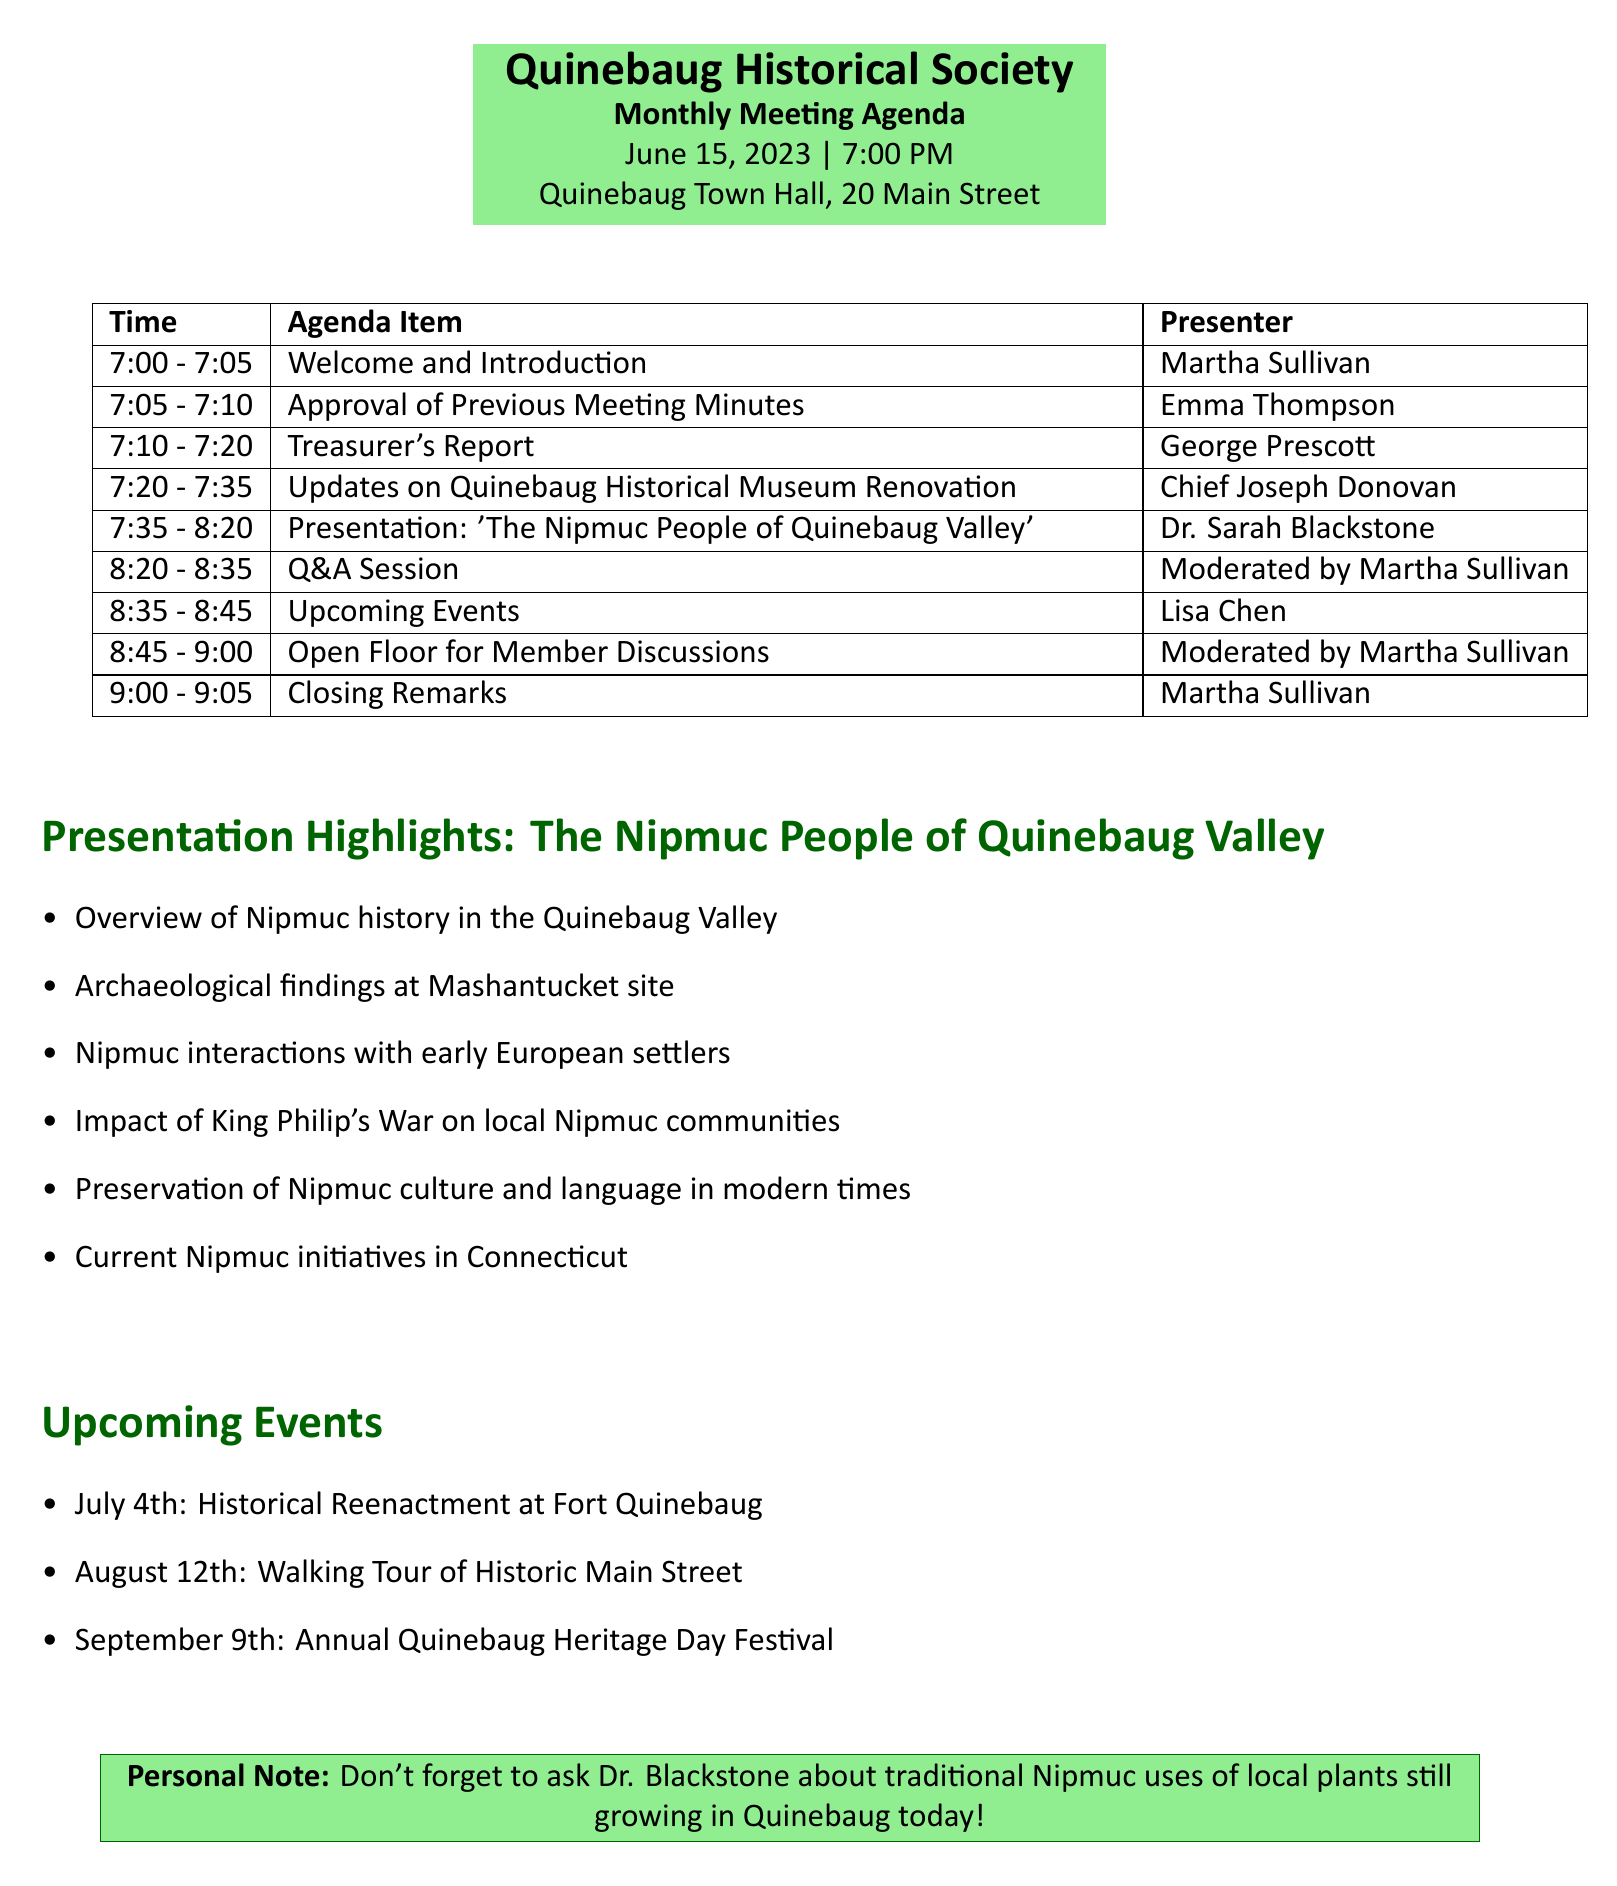What is the date of the meeting? The date of the meeting can be found in the meeting details section of the document.
Answer: June 15, 2023 Who is the presenter for the Treasurer's Report? The presenter for the Treasurer's Report is listed in the agenda items.
Answer: George Prescott What time does the meeting start? The meeting start time is indicated in the meeting details at the top of the document.
Answer: 7:00 PM How long is Dr. Sarah Blackstone's presentation? The duration of Dr. Blackstone's presentation is mentioned in the agenda items section.
Answer: 45 minutes What is one local connection mentioned in the presentation details? Local connections can be found listed in the presentation details section.
Answer: Quinebaug River's significance in Nipmuc life What are the dates for the upcoming events? The upcoming events are enumerated in the section dedicated to upcoming events.
Answer: July 4th, August 12th, September 9th Who will moderate the Q&A Session? The moderator for the Q&A session is specified in the agenda items.
Answer: Martha Sullivan What kind of items will be discussed in the Open Floor? Open Floor discussions are generally specified in the agenda format for member discussions.
Answer: Member Discussions 